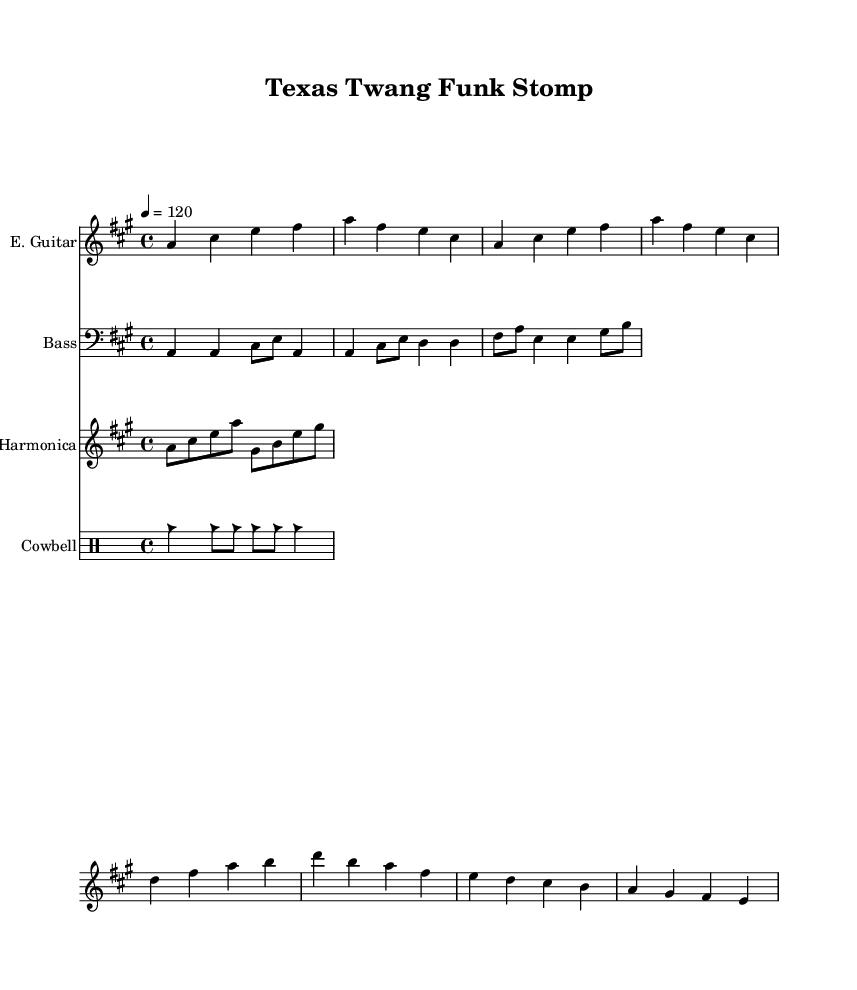What is the key signature of this music? The key signature is A major, which has three sharps (F#, C#, and G#). You can identify the key signature at the start of the sheet music, indicated by the sharp symbols.
Answer: A major What is the time signature of this piece? The time signature is 4/4, which is shown at the beginning of the music. This means there are four beats per measure, and each quarter note gets one beat.
Answer: 4/4 What is the tempo indicated in the music? The tempo marking is 120 beats per minute, which is noted above the music staff. This indicates how fast the piece should be played.
Answer: 120 How many measures are there in the electric guitar part? The electric guitar part has a total of eight measures. You can count the measures by looking for the vertical bar lines that separate each measure in the music.
Answer: Eight Which instrument plays the cowbell rhythm? The cowbell is played in the drum section, specifically indicated as a "Cowbell" in the instrument section of the sheet music.
Answer: Cowbell What note does the harmonica start on? The harmonica starts on the note A, which is the first note written in the harmonica part before any other notes.
Answer: A What is the primary rhythm type used in the bass guitar part? The bass guitar part mainly uses quarter notes and eighth notes, which create a steady groove characteristic of funk music. You can observe the rhythmic structure in the bass guitar measures.
Answer: Quarter and eighth notes 